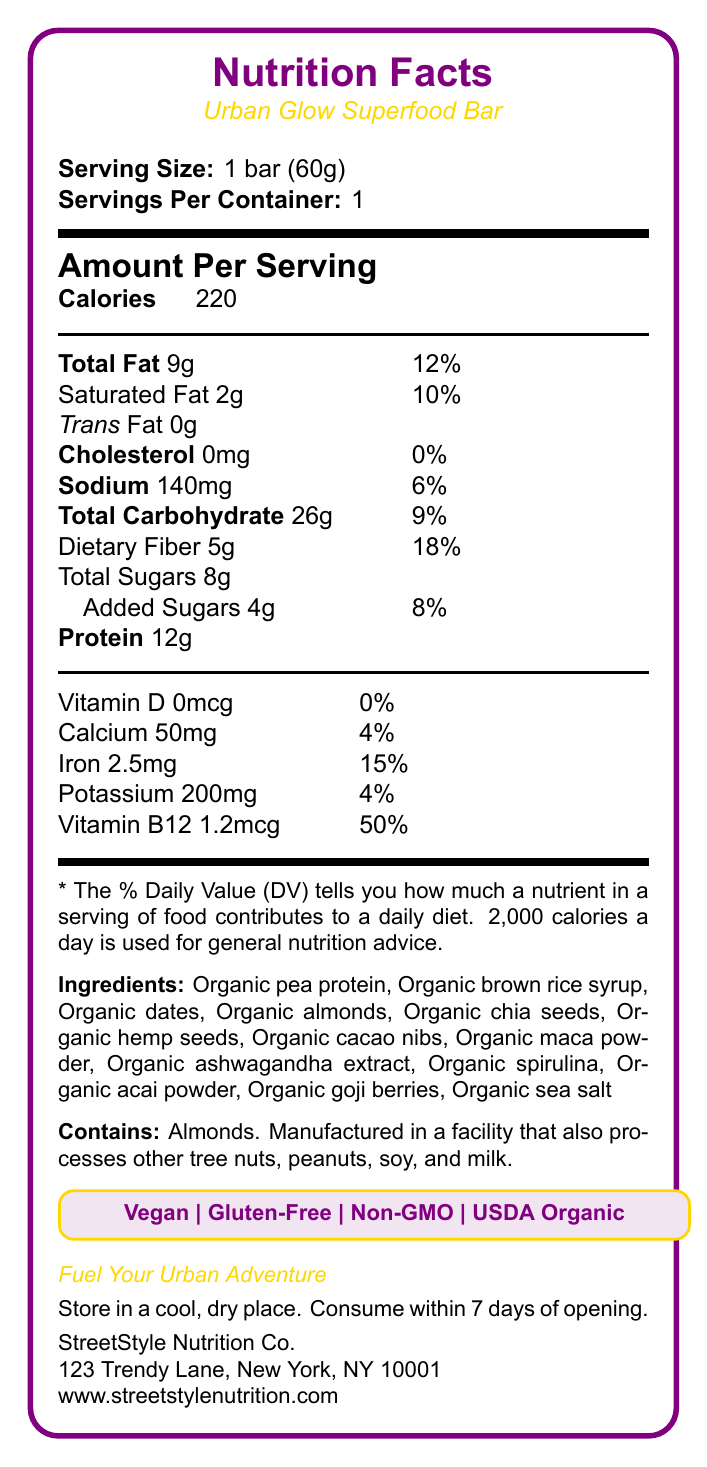what is the serving size? The serving size is explicitly stated as "1 bar (60g)" in the document.
Answer: 1 bar (60g) how many calories are in one serving of the Urban Glow Superfood Bar? The document specifies "Calories: 220" per serving, which is one bar.
Answer: 220 calories what is the total fat content per serving? The document lists "Total Fat: 9g" for each serving.
Answer: 9g what are the ingredients in the Urban Glow Superfood Bar? The ingredients are clearly listed under the "Ingredients" section in the document.
Answer: Organic pea protein, Organic brown rice syrup, Organic dates, Organic almonds, Organic chia seeds, Organic hemp seeds, Organic cacao nibs, Organic maca powder, Organic ashwagandha extract, Organic spirulina, Organic acai powder, Organic goji berries, Organic sea salt where is StreetStyle Nutrition Co. located? The document provides the company address at the end: "123 Trendy Lane, New York, NY 10001".
Answer: 123 Trendy Lane, New York, NY 10001 how much protein does one bar contain? The document specifies "Protein: 12g" for each serving.
Answer: 12g are there any added sugars in the bar? The document mentions "Added Sugars: 4g" under the nutrition facts.
Answer: Yes which claim is NOT associated with the Urban Glow Superfood Bar? A. Vegan B. Gluten-Free C. Keto-Friendly D. Non-GMO E. USDA Organic The document lists "Vegan," "Gluten-Free," "Non-GMO," and "USDA Organic," but it does not mention "Keto-Friendly."
Answer: C. Keto-Friendly how much dietary fiber is in one bar? The document details "Dietary Fiber: 5g" per serving.
Answer: 5g what vitamins and minerals are listed in the nutrition facts? The vitamins and minerals mentioned are Vitamin D (0mcg), Calcium (50mg), Iron (2.5mg), Potassium (200mg), and Vitamin B12 (1.2mcg).
Answer: Vitamin D, Calcium, Iron, Potassium, Vitamin B12 does the bar contain any allergens? The document states "Contains: Almonds. Manufactured in a facility that also processes other tree nuts, peanuts, soy, and milk."
Answer: Yes what is the daily percentage value of iron in one serving? The document lists "Iron: 2.5mg" with a daily value of 15%.
Answer: 15% what should you do after opening the bar's packaging? The storage instructions note, "Consume within 7 days of opening."
Answer: Consume within 7 days how much sodium does one serving contain? A. 50mg B. 100mg C. 140mg D. 200mg The document specifies "Sodium: 140mg" per serving.
Answer: C. 140mg is this product vegan? The document explicitly states that the bar is "Vegan."
Answer: Yes describe the main components of the Urban Glow Superfood Bar. The document provides comprehensive nutrition facts, ingredient details, claims, and company information for the Urban Glow Superfood Bar.
Answer: The Urban Glow Superfood Bar by StreetStyle Nutrition Co. is a plant-based protein bar with superfoods and adaptogenic herbs. It contains 220 calories, 9g of total fat, 12g of protein, and 5g of dietary fiber per serving. It includes various organic ingredients like pea protein, dates, and almonds, and it is vegan, gluten-free, non-GMO, and USDA Organic certified. The product should be stored in a cool, dry place and consumed within 7 days of opening. how much Vitamin C does one bar contain? The document does not mention Vitamin C content.
Answer: Not enough information 